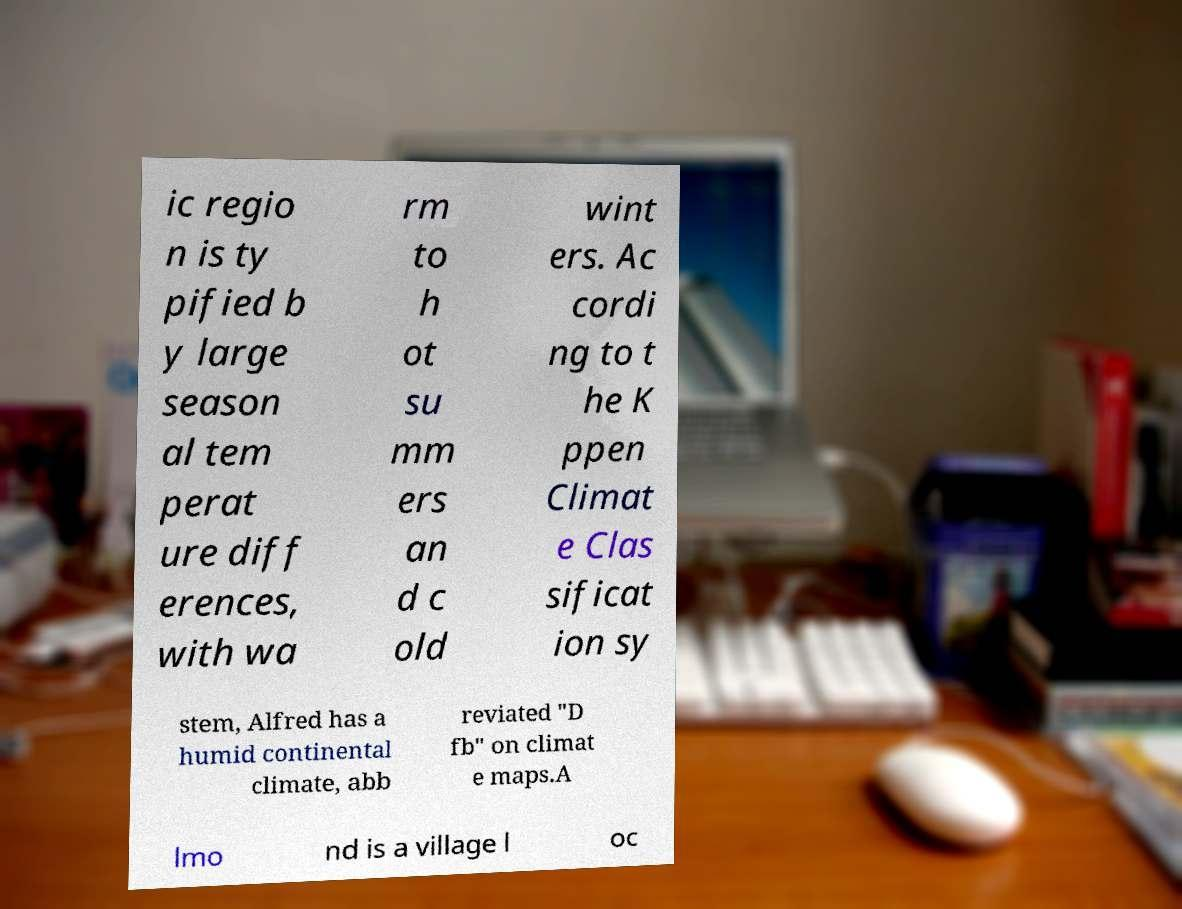What messages or text are displayed in this image? I need them in a readable, typed format. ic regio n is ty pified b y large season al tem perat ure diff erences, with wa rm to h ot su mm ers an d c old wint ers. Ac cordi ng to t he K ppen Climat e Clas sificat ion sy stem, Alfred has a humid continental climate, abb reviated "D fb" on climat e maps.A lmo nd is a village l oc 